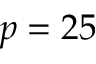Convert formula to latex. <formula><loc_0><loc_0><loc_500><loc_500>p = 2 5</formula> 